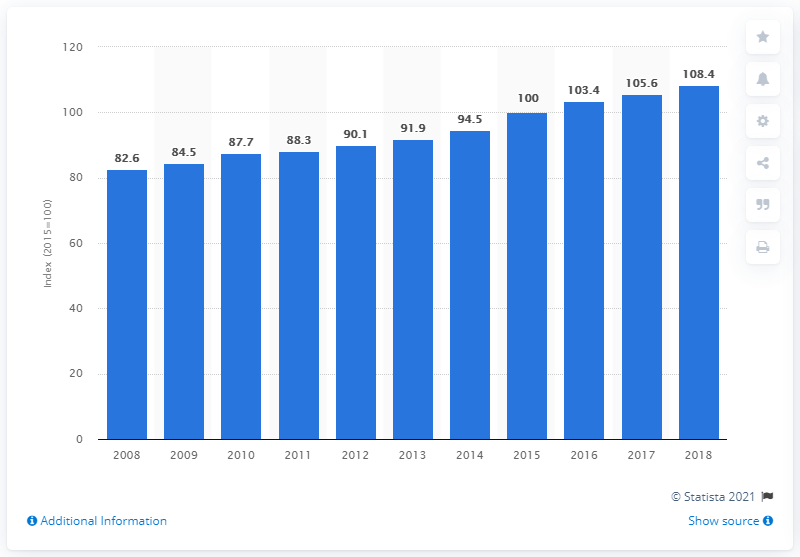Mention a couple of crucial points in this snapshot. In 2015, the index was measured at 108.4. In 2018, the index for retail trade sales in Sweden was 108.4. 